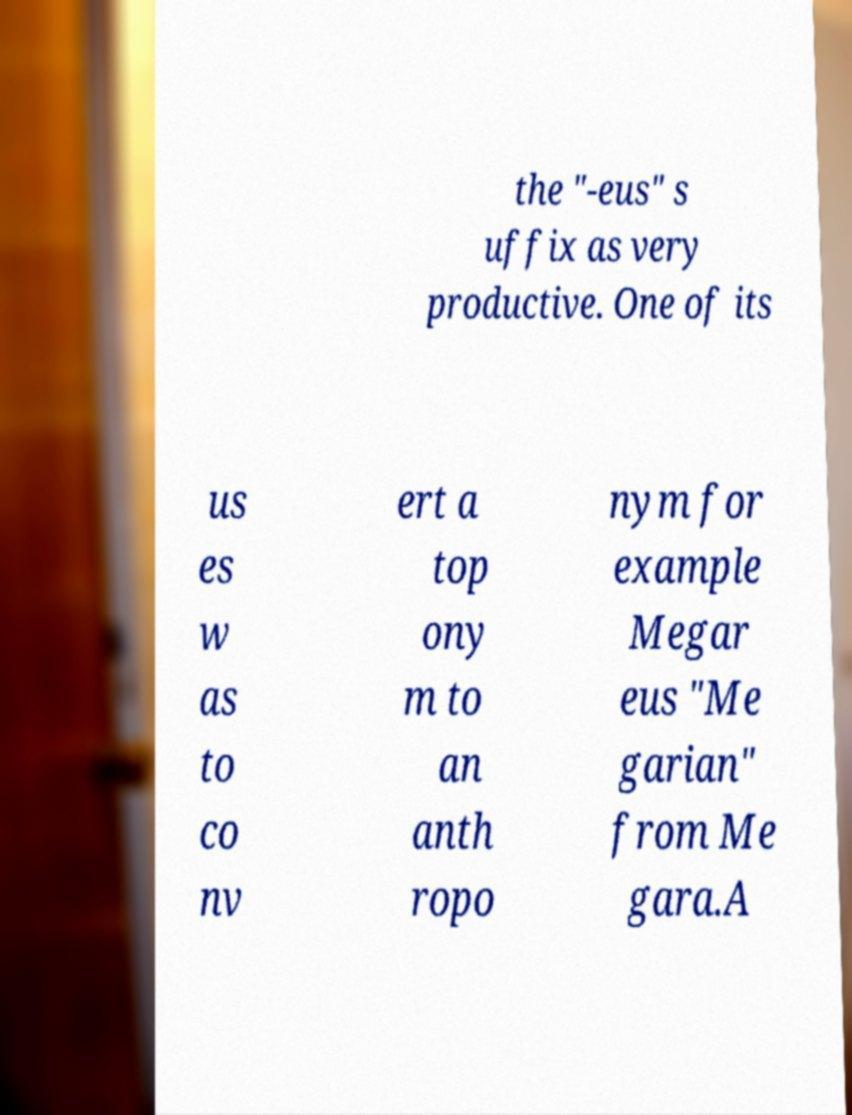Could you extract and type out the text from this image? the "-eus" s uffix as very productive. One of its us es w as to co nv ert a top ony m to an anth ropo nym for example Megar eus "Me garian" from Me gara.A 